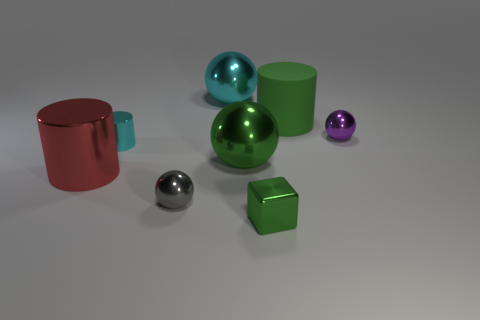Is the number of green objects to the left of the matte thing greater than the number of big metal spheres?
Your answer should be compact. No. Are there any other things that have the same material as the large green cylinder?
Your response must be concise. No. Do the metal sphere behind the big green rubber cylinder and the tiny object that is left of the gray object have the same color?
Provide a succinct answer. Yes. What material is the green thing that is in front of the small metal ball in front of the small metallic thing that is behind the cyan cylinder?
Give a very brief answer. Metal. Is the number of tiny metal balls greater than the number of big red things?
Make the answer very short. Yes. Is there any other thing that is the same color as the cube?
Make the answer very short. Yes. What size is the red cylinder that is the same material as the tiny purple thing?
Make the answer very short. Large. What is the material of the big cyan object?
Your response must be concise. Metal. What number of blocks are the same size as the gray metallic object?
Offer a very short reply. 1. There is a metallic thing that is the same color as the tiny cylinder; what is its shape?
Ensure brevity in your answer.  Sphere. 